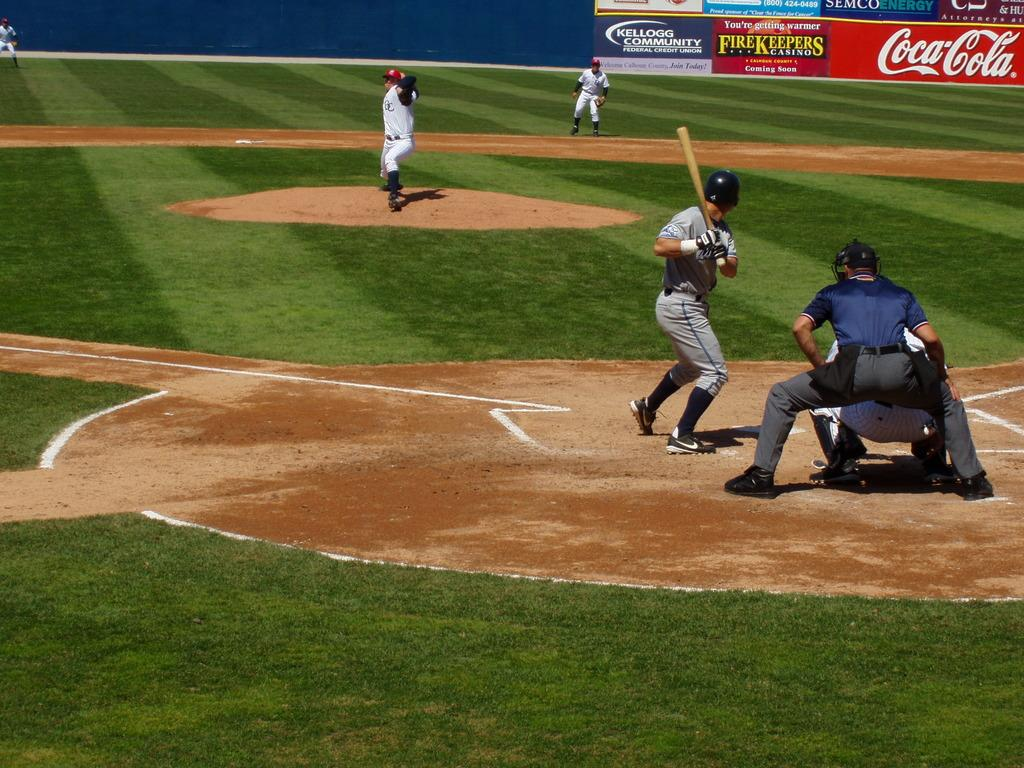<image>
Give a short and clear explanation of the subsequent image. some players getting ready to play with a Coca Cola advertisement in the outfield 